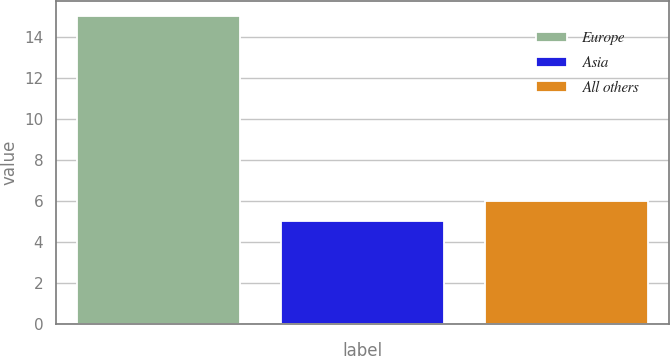Convert chart. <chart><loc_0><loc_0><loc_500><loc_500><bar_chart><fcel>Europe<fcel>Asia<fcel>All others<nl><fcel>15<fcel>5<fcel>6<nl></chart> 